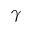Convert formula to latex. <formula><loc_0><loc_0><loc_500><loc_500>\gamma</formula> 